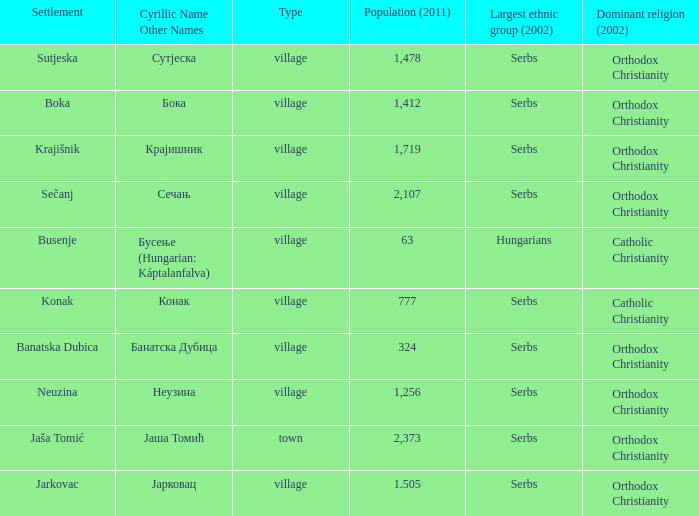The pooulation of јарковац is? 1.505. 